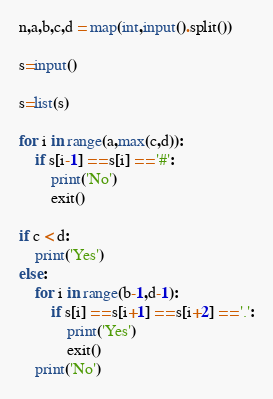Convert code to text. <code><loc_0><loc_0><loc_500><loc_500><_Python_>n,a,b,c,d = map(int,input().split())

s=input()

s=list(s)

for i in range(a,max(c,d)):
    if s[i-1] == s[i] == '#':
        print('No')
        exit()

if c < d:
    print('Yes')
else:
    for i in range(b-1,d-1):
        if s[i] == s[i+1] == s[i+2] == '.':
            print('Yes')
            exit()
    print('No')
</code> 